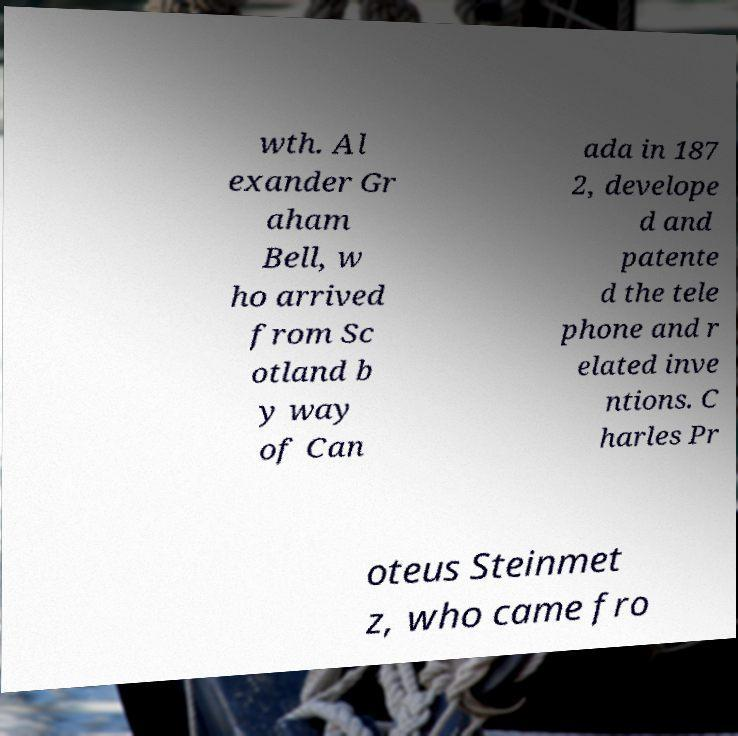Please read and relay the text visible in this image. What does it say? wth. Al exander Gr aham Bell, w ho arrived from Sc otland b y way of Can ada in 187 2, develope d and patente d the tele phone and r elated inve ntions. C harles Pr oteus Steinmet z, who came fro 